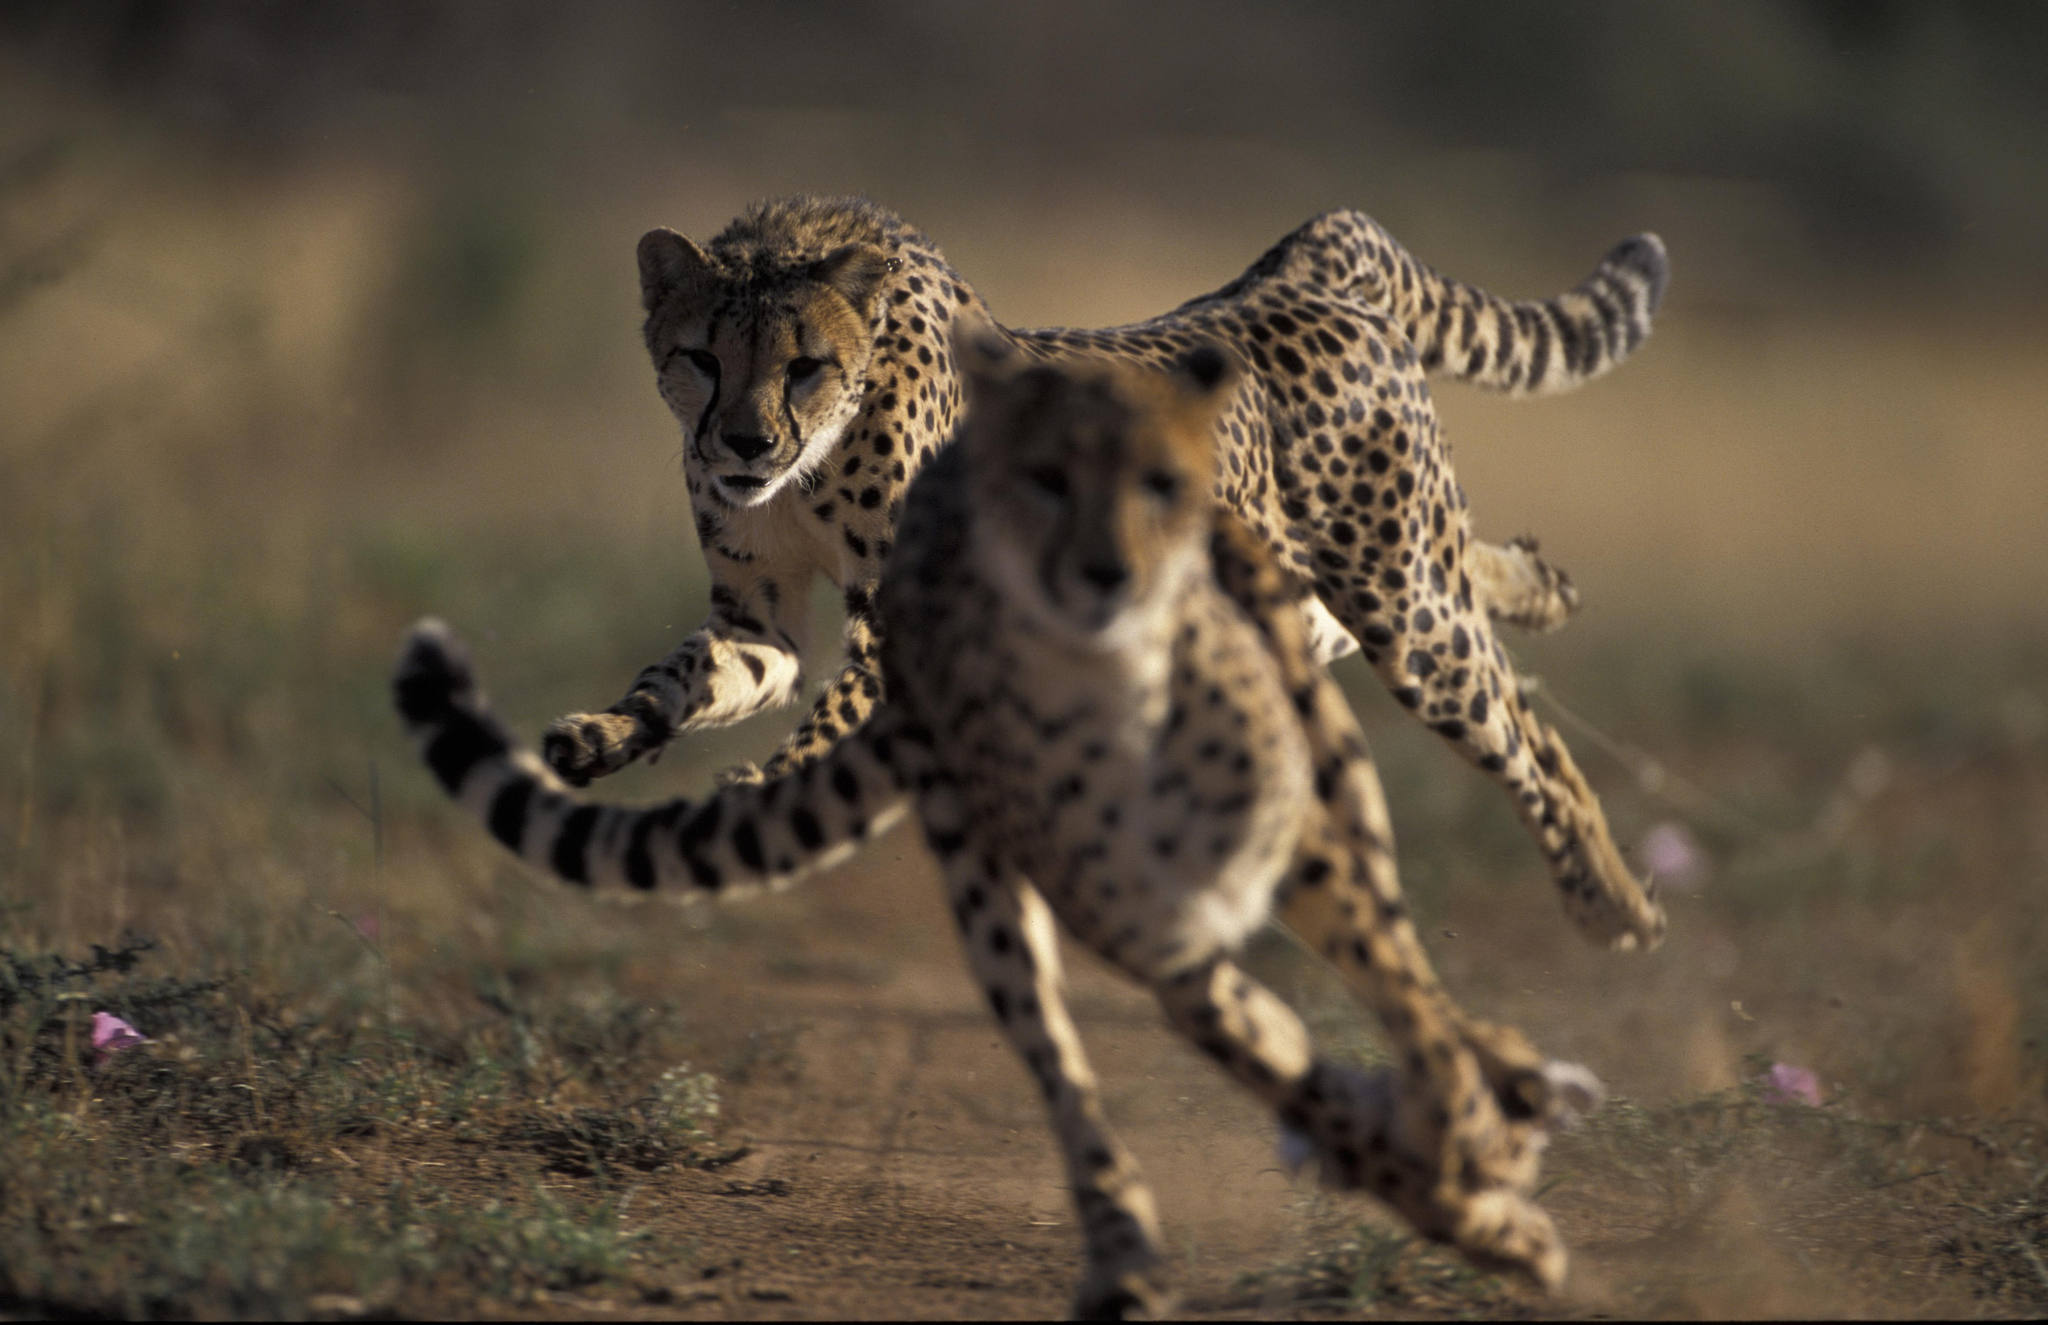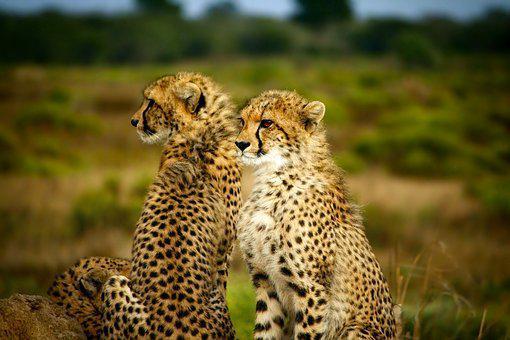The first image is the image on the left, the second image is the image on the right. Considering the images on both sides, is "2 cheetahs are laying in green grass" valid? Answer yes or no. No. The first image is the image on the left, the second image is the image on the right. Examine the images to the left and right. Is the description "One image has two Cheetahs with one licking the other." accurate? Answer yes or no. No. 